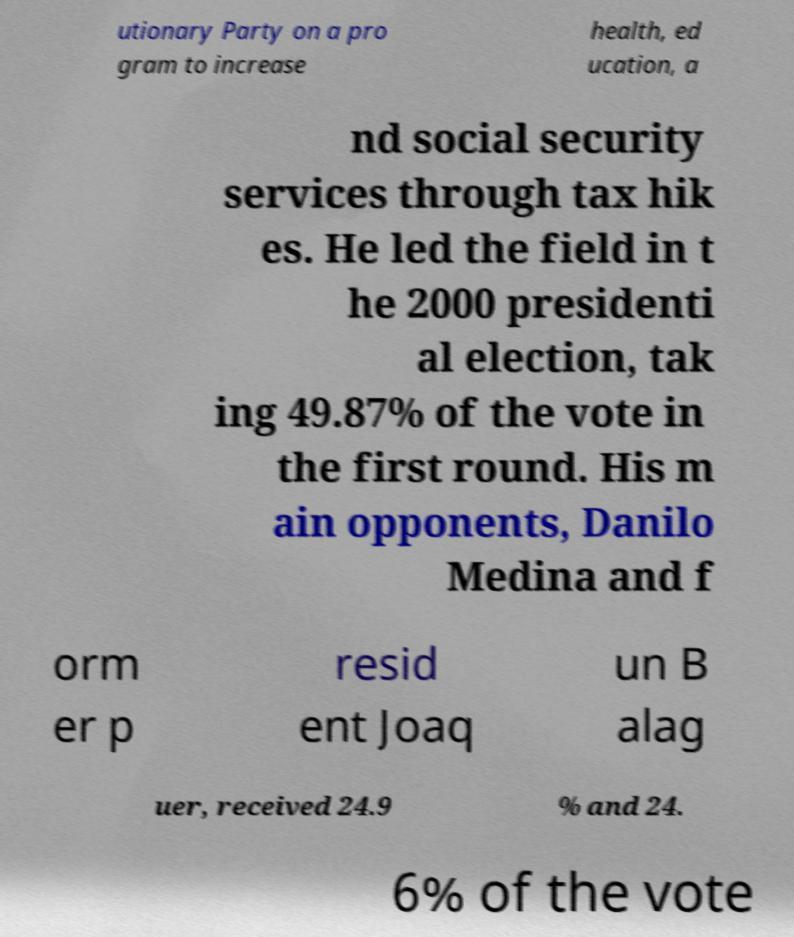Could you assist in decoding the text presented in this image and type it out clearly? utionary Party on a pro gram to increase health, ed ucation, a nd social security services through tax hik es. He led the field in t he 2000 presidenti al election, tak ing 49.87% of the vote in the first round. His m ain opponents, Danilo Medina and f orm er p resid ent Joaq un B alag uer, received 24.9 % and 24. 6% of the vote 